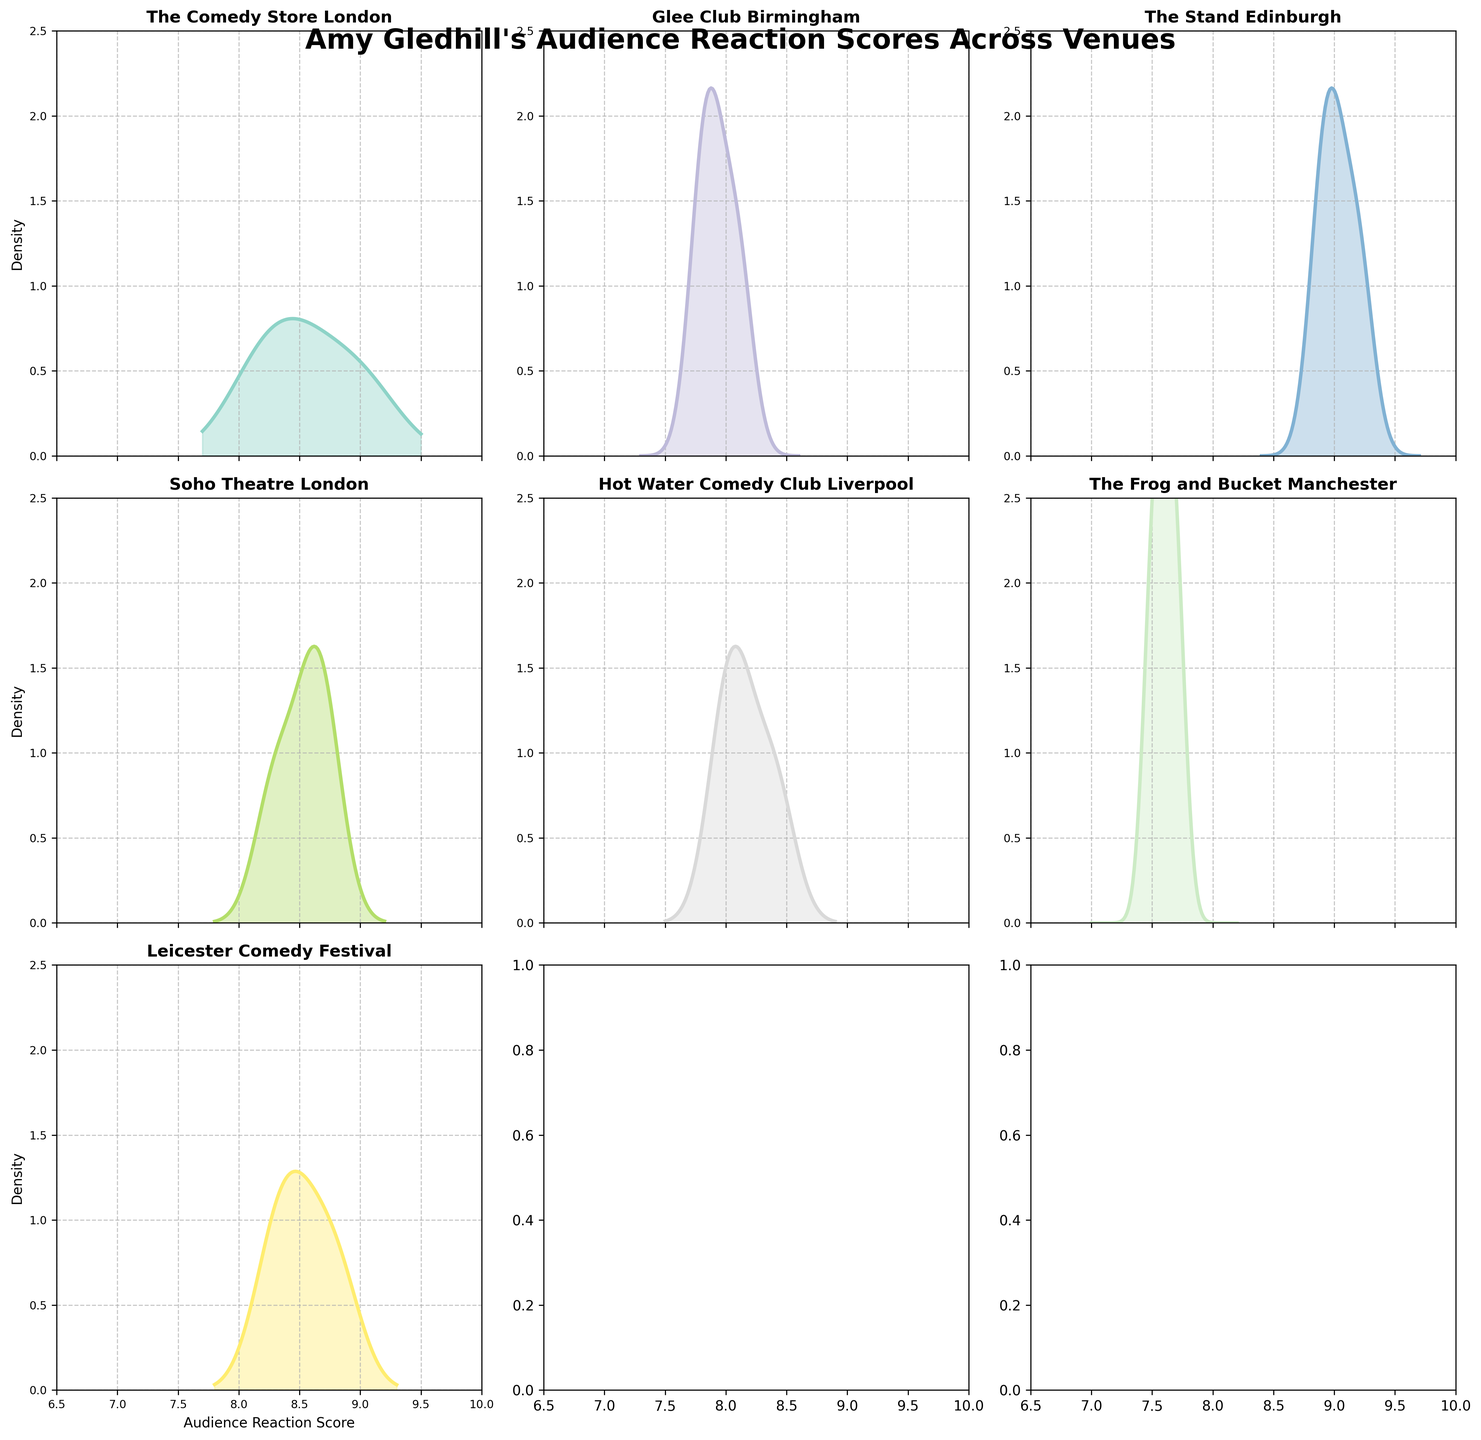What's the title of the figure? The title of the figure is displayed at the top center of the plot, which reads "Amy Gledhill's Audience Reaction Scores Across Venues."
Answer: Amy Gledhill's Audience Reaction Scores Across Venues What are the axis labels for the subplots? The x-axis is labeled "Audience Reaction Score," and the y-axis is labeled "Density." These labels are visible on the bottom row of subplots and the leftmost subplots.
Answer: Audience Reaction Score, Density Which venue has the highest density peak? By visually inspecting the density plots, The Stand Edinburgh has the highest peak around 9.0, indicating that reactions for this venue are consistently high.
Answer: The Stand Edinburgh How many subplots are there? The figure is a subplot layout with 3 rows and 3 columns, making a total of 9 subplots. This can be inferred from the 3x3 grid presented.
Answer: 9 Which venue has the lowest audience reaction scores based on the density plot? The Frog and Bucket Manchester has lower reaction scores peaking around 7.5 – 7.7, with no high peaks close to 9 or 10.
Answer: The Frog and Bucket Manchester In which range do most of the audience reaction scores for The Comedy Store London fall? Inspecting the density plot for The Comedy Store London, it is evident that most audience reaction scores fall between 8.0 and 9.5.
Answer: 8.0 to 9.5 Compare the density peaks of Glee Club Birmingham and The Stand Edinburgh. Which one is higher? The Stand Edinburgh has a noticeably higher density peak than Glee Club Birmingham, with its peak around 2.0 versus Glee Club Birmingham's peak around 1.2.
Answer: The Stand Edinburgh Which venues have peaks in their density plots higher than 1.0? Based on the density plots, The Comedy Store London, The Stand Edinburgh, and Leicester Comedy Festival have peaks that exceed 1.0.
Answer: The Comedy Store London, The Stand Edinburgh, Leicester Comedy Festival What is the approximate range of audience reaction scores in all venues? By observing the x-axis limits across all subplots, the range for scores across all venues lies between 6.5 and 10.
Answer: 6.5 to 10 